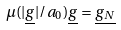<formula> <loc_0><loc_0><loc_500><loc_500>\mu ( | \underline { g } | / a _ { 0 } ) \underline { g } = \underline { g _ { N } }</formula> 